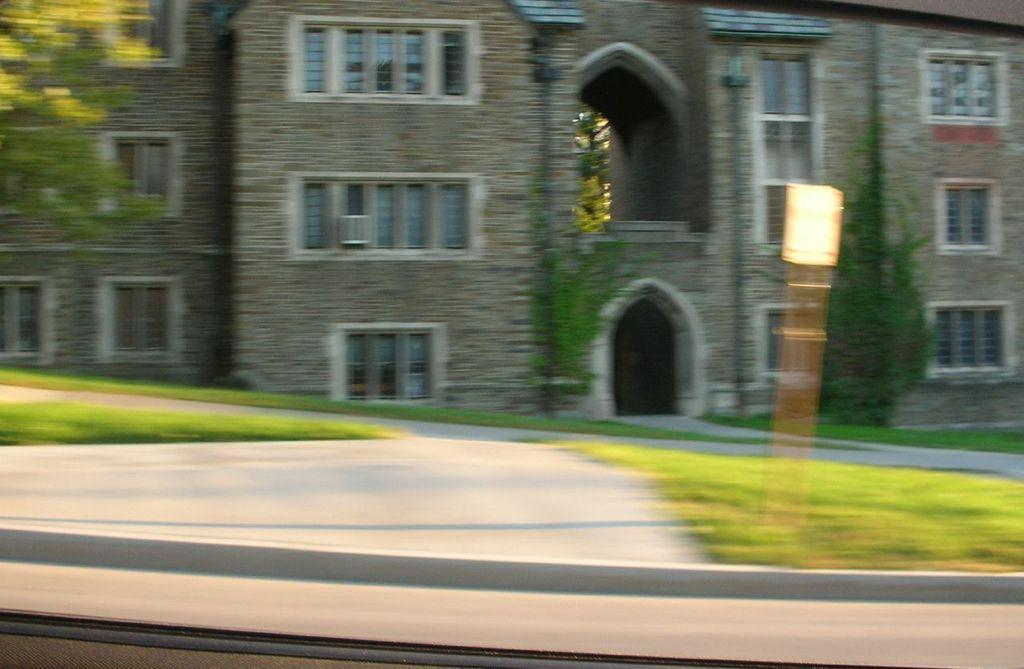What type of structure is present in the image? There is a building with windows in the image. What can be seen near the building? There are plants near the building. What is the path used for in the image? The path is visible in the image. What type of surface is on both sides of the path? The grass surface is visible on both sides of the path. What type of toothpaste is used to clean the windows of the building in the image? There is no toothpaste mentioned or visible in the image, and toothpaste is not used to clean windows. 